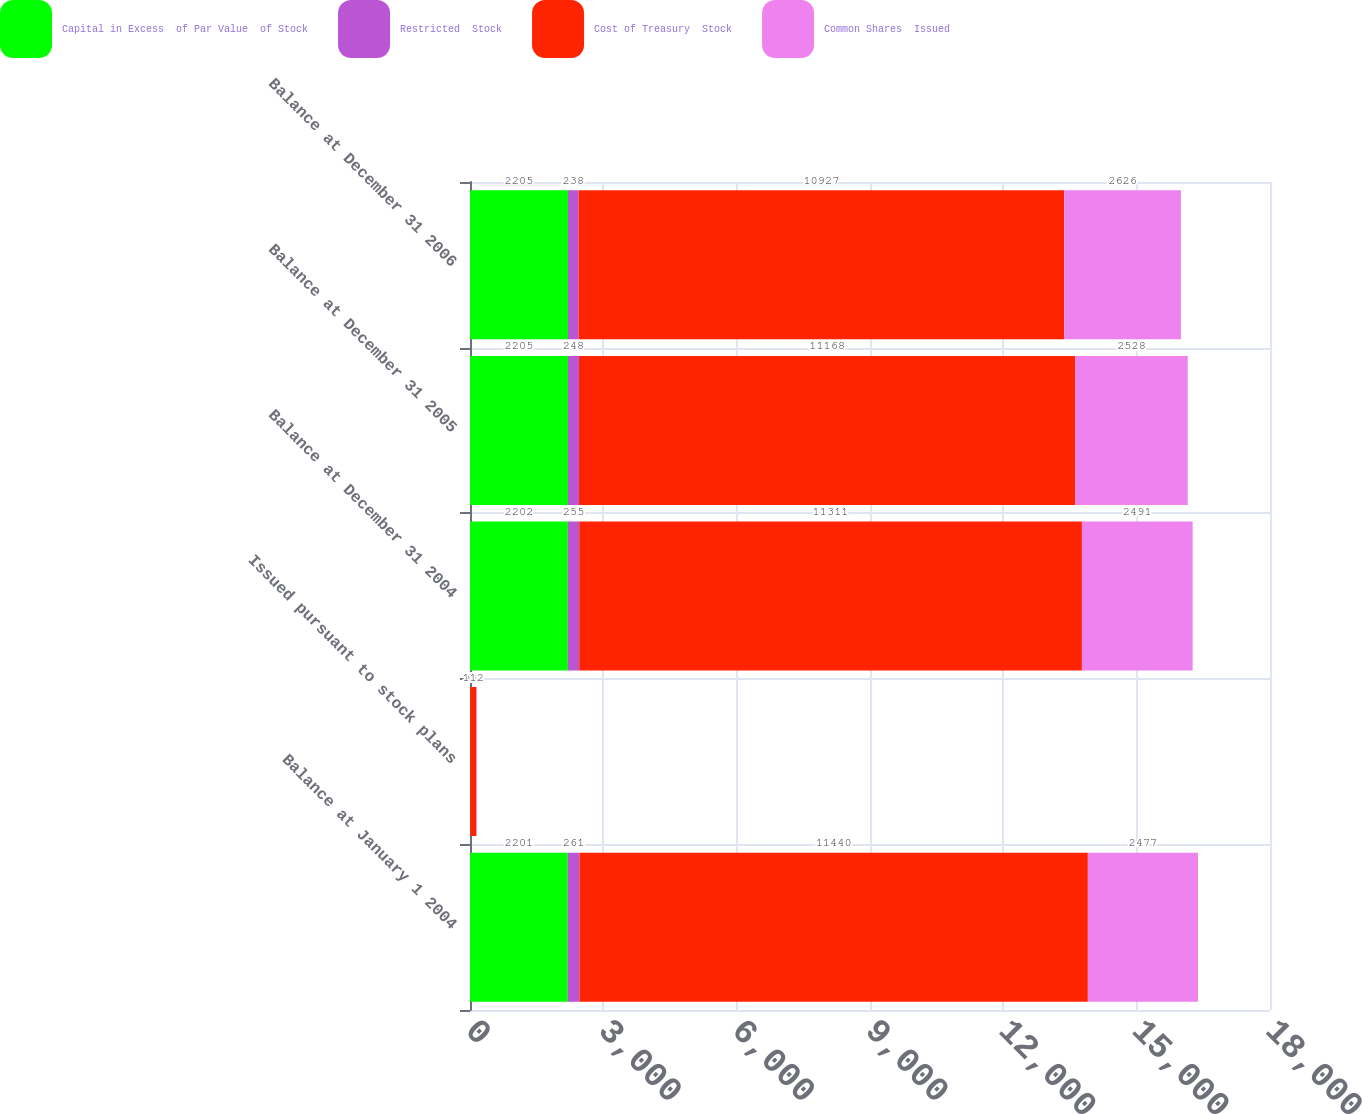Convert chart to OTSL. <chart><loc_0><loc_0><loc_500><loc_500><stacked_bar_chart><ecel><fcel>Balance at January 1 2004<fcel>Issued pursuant to stock plans<fcel>Balance at December 31 2004<fcel>Balance at December 31 2005<fcel>Balance at December 31 2006<nl><fcel>Capital in Excess  of Par Value  of Stock<fcel>2201<fcel>1<fcel>2202<fcel>2205<fcel>2205<nl><fcel>Restricted  Stock<fcel>261<fcel>6<fcel>255<fcel>248<fcel>238<nl><fcel>Cost of Treasury  Stock<fcel>11440<fcel>137<fcel>11311<fcel>11168<fcel>10927<nl><fcel>Common Shares  Issued<fcel>2477<fcel>12<fcel>2491<fcel>2528<fcel>2626<nl></chart> 